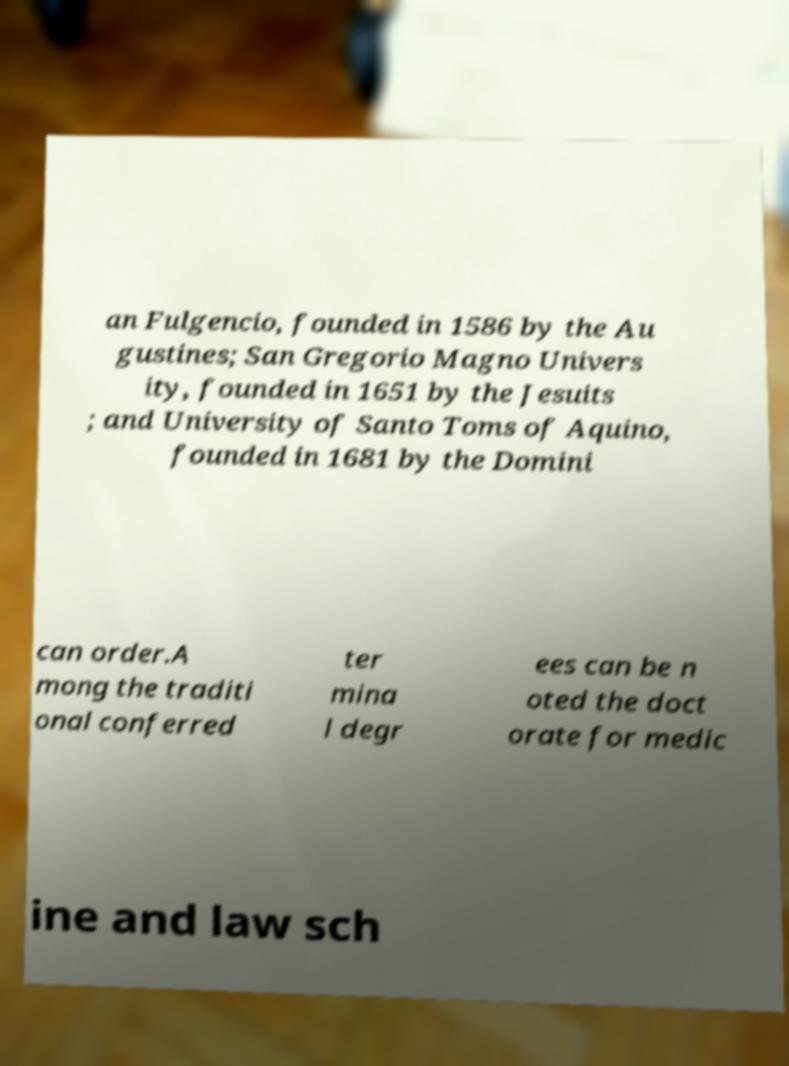What messages or text are displayed in this image? I need them in a readable, typed format. an Fulgencio, founded in 1586 by the Au gustines; San Gregorio Magno Univers ity, founded in 1651 by the Jesuits ; and University of Santo Toms of Aquino, founded in 1681 by the Domini can order.A mong the traditi onal conferred ter mina l degr ees can be n oted the doct orate for medic ine and law sch 